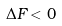Convert formula to latex. <formula><loc_0><loc_0><loc_500><loc_500>\Delta F < 0</formula> 